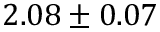<formula> <loc_0><loc_0><loc_500><loc_500>2 . 0 8 \pm 0 . 0 7</formula> 